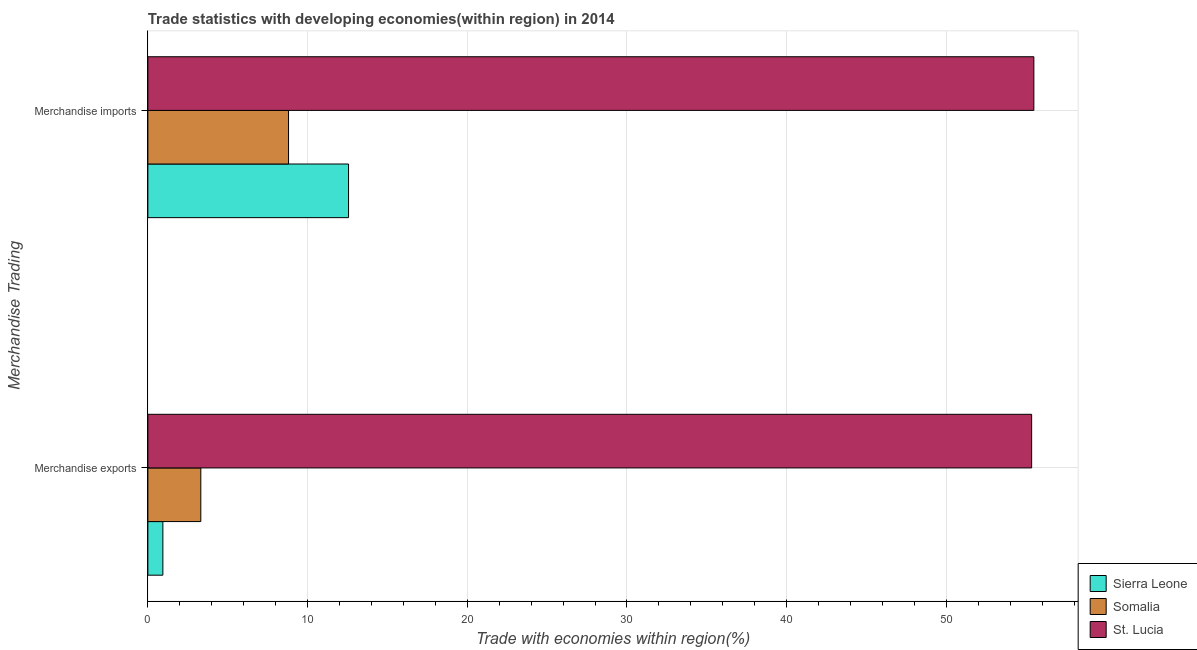How many groups of bars are there?
Provide a succinct answer. 2. What is the label of the 1st group of bars from the top?
Provide a succinct answer. Merchandise imports. What is the merchandise imports in Sierra Leone?
Ensure brevity in your answer.  12.57. Across all countries, what is the maximum merchandise imports?
Your response must be concise. 55.48. Across all countries, what is the minimum merchandise exports?
Offer a very short reply. 0.94. In which country was the merchandise exports maximum?
Make the answer very short. St. Lucia. In which country was the merchandise imports minimum?
Your answer should be very brief. Somalia. What is the total merchandise exports in the graph?
Offer a very short reply. 59.59. What is the difference between the merchandise exports in St. Lucia and that in Somalia?
Provide a succinct answer. 52.02. What is the difference between the merchandise imports in St. Lucia and the merchandise exports in Somalia?
Your response must be concise. 52.16. What is the average merchandise exports per country?
Give a very brief answer. 19.86. What is the difference between the merchandise imports and merchandise exports in St. Lucia?
Make the answer very short. 0.14. What is the ratio of the merchandise exports in St. Lucia to that in Somalia?
Ensure brevity in your answer.  16.69. Is the merchandise exports in St. Lucia less than that in Sierra Leone?
Provide a short and direct response. No. What does the 2nd bar from the top in Merchandise imports represents?
Ensure brevity in your answer.  Somalia. What does the 3rd bar from the bottom in Merchandise imports represents?
Make the answer very short. St. Lucia. Are all the bars in the graph horizontal?
Your response must be concise. Yes. Are the values on the major ticks of X-axis written in scientific E-notation?
Make the answer very short. No. Does the graph contain grids?
Provide a succinct answer. Yes. What is the title of the graph?
Ensure brevity in your answer.  Trade statistics with developing economies(within region) in 2014. Does "Belgium" appear as one of the legend labels in the graph?
Your answer should be compact. No. What is the label or title of the X-axis?
Offer a terse response. Trade with economies within region(%). What is the label or title of the Y-axis?
Provide a succinct answer. Merchandise Trading. What is the Trade with economies within region(%) of Sierra Leone in Merchandise exports?
Keep it short and to the point. 0.94. What is the Trade with economies within region(%) in Somalia in Merchandise exports?
Provide a succinct answer. 3.32. What is the Trade with economies within region(%) in St. Lucia in Merchandise exports?
Your answer should be very brief. 55.34. What is the Trade with economies within region(%) in Sierra Leone in Merchandise imports?
Provide a short and direct response. 12.57. What is the Trade with economies within region(%) in Somalia in Merchandise imports?
Make the answer very short. 8.81. What is the Trade with economies within region(%) in St. Lucia in Merchandise imports?
Your response must be concise. 55.48. Across all Merchandise Trading, what is the maximum Trade with economies within region(%) of Sierra Leone?
Your response must be concise. 12.57. Across all Merchandise Trading, what is the maximum Trade with economies within region(%) in Somalia?
Your response must be concise. 8.81. Across all Merchandise Trading, what is the maximum Trade with economies within region(%) in St. Lucia?
Keep it short and to the point. 55.48. Across all Merchandise Trading, what is the minimum Trade with economies within region(%) of Sierra Leone?
Provide a succinct answer. 0.94. Across all Merchandise Trading, what is the minimum Trade with economies within region(%) in Somalia?
Provide a succinct answer. 3.32. Across all Merchandise Trading, what is the minimum Trade with economies within region(%) of St. Lucia?
Ensure brevity in your answer.  55.34. What is the total Trade with economies within region(%) of Sierra Leone in the graph?
Ensure brevity in your answer.  13.51. What is the total Trade with economies within region(%) of Somalia in the graph?
Keep it short and to the point. 12.12. What is the total Trade with economies within region(%) of St. Lucia in the graph?
Give a very brief answer. 110.82. What is the difference between the Trade with economies within region(%) in Sierra Leone in Merchandise exports and that in Merchandise imports?
Keep it short and to the point. -11.63. What is the difference between the Trade with economies within region(%) of Somalia in Merchandise exports and that in Merchandise imports?
Your answer should be compact. -5.49. What is the difference between the Trade with economies within region(%) of St. Lucia in Merchandise exports and that in Merchandise imports?
Keep it short and to the point. -0.14. What is the difference between the Trade with economies within region(%) of Sierra Leone in Merchandise exports and the Trade with economies within region(%) of Somalia in Merchandise imports?
Make the answer very short. -7.87. What is the difference between the Trade with economies within region(%) of Sierra Leone in Merchandise exports and the Trade with economies within region(%) of St. Lucia in Merchandise imports?
Your answer should be very brief. -54.54. What is the difference between the Trade with economies within region(%) of Somalia in Merchandise exports and the Trade with economies within region(%) of St. Lucia in Merchandise imports?
Provide a short and direct response. -52.16. What is the average Trade with economies within region(%) of Sierra Leone per Merchandise Trading?
Ensure brevity in your answer.  6.75. What is the average Trade with economies within region(%) in Somalia per Merchandise Trading?
Offer a very short reply. 6.06. What is the average Trade with economies within region(%) in St. Lucia per Merchandise Trading?
Your answer should be compact. 55.41. What is the difference between the Trade with economies within region(%) in Sierra Leone and Trade with economies within region(%) in Somalia in Merchandise exports?
Provide a succinct answer. -2.38. What is the difference between the Trade with economies within region(%) in Sierra Leone and Trade with economies within region(%) in St. Lucia in Merchandise exports?
Provide a short and direct response. -54.4. What is the difference between the Trade with economies within region(%) of Somalia and Trade with economies within region(%) of St. Lucia in Merchandise exports?
Offer a terse response. -52.02. What is the difference between the Trade with economies within region(%) in Sierra Leone and Trade with economies within region(%) in Somalia in Merchandise imports?
Give a very brief answer. 3.76. What is the difference between the Trade with economies within region(%) in Sierra Leone and Trade with economies within region(%) in St. Lucia in Merchandise imports?
Keep it short and to the point. -42.91. What is the difference between the Trade with economies within region(%) of Somalia and Trade with economies within region(%) of St. Lucia in Merchandise imports?
Ensure brevity in your answer.  -46.67. What is the ratio of the Trade with economies within region(%) in Sierra Leone in Merchandise exports to that in Merchandise imports?
Your answer should be very brief. 0.07. What is the ratio of the Trade with economies within region(%) in Somalia in Merchandise exports to that in Merchandise imports?
Keep it short and to the point. 0.38. What is the ratio of the Trade with economies within region(%) of St. Lucia in Merchandise exports to that in Merchandise imports?
Provide a short and direct response. 1. What is the difference between the highest and the second highest Trade with economies within region(%) in Sierra Leone?
Offer a terse response. 11.63. What is the difference between the highest and the second highest Trade with economies within region(%) in Somalia?
Offer a terse response. 5.49. What is the difference between the highest and the second highest Trade with economies within region(%) in St. Lucia?
Make the answer very short. 0.14. What is the difference between the highest and the lowest Trade with economies within region(%) in Sierra Leone?
Your answer should be very brief. 11.63. What is the difference between the highest and the lowest Trade with economies within region(%) in Somalia?
Offer a very short reply. 5.49. What is the difference between the highest and the lowest Trade with economies within region(%) of St. Lucia?
Offer a very short reply. 0.14. 